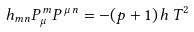<formula> <loc_0><loc_0><loc_500><loc_500>h _ { m n } P ^ { \, m } _ { \mu } P ^ { \, \mu \, n } = - ( p + 1 ) \, h \, T ^ { 2 }</formula> 